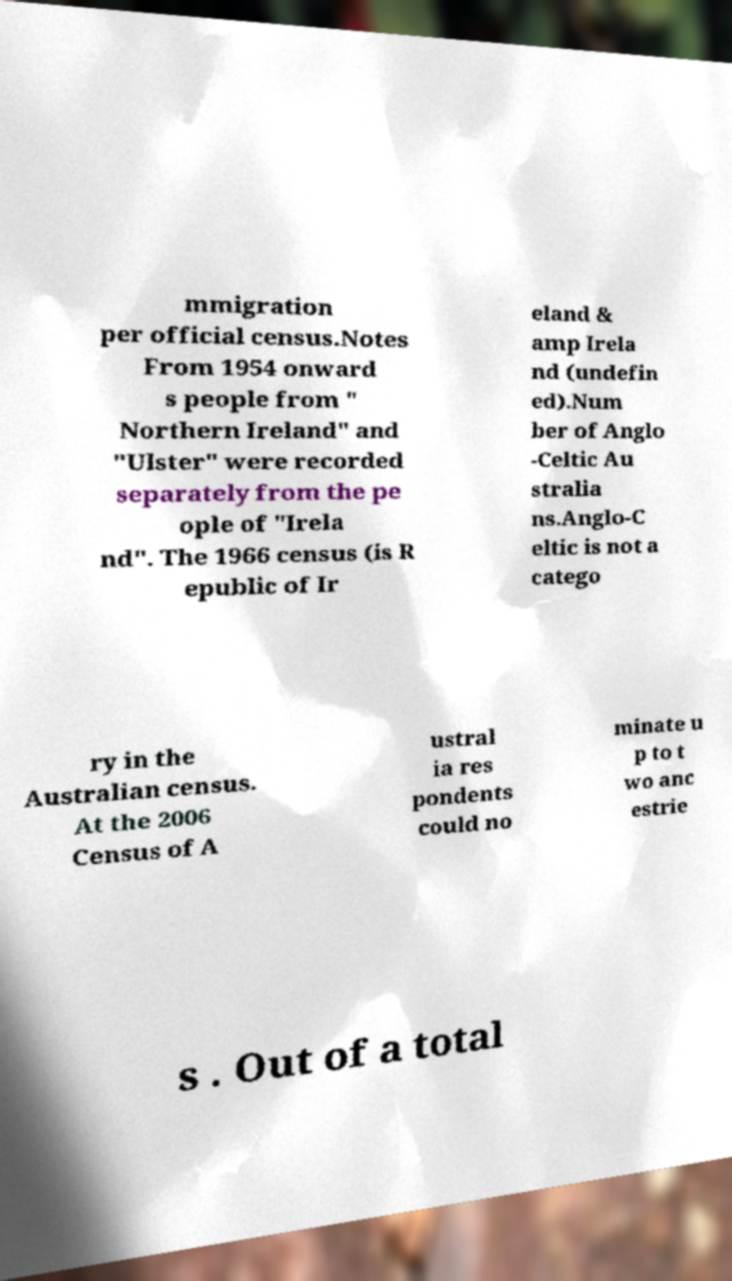Please read and relay the text visible in this image. What does it say? mmigration per official census.Notes From 1954 onward s people from " Northern Ireland" and "Ulster" were recorded separately from the pe ople of "Irela nd". The 1966 census (is R epublic of Ir eland & amp Irela nd (undefin ed).Num ber of Anglo -Celtic Au stralia ns.Anglo-C eltic is not a catego ry in the Australian census. At the 2006 Census of A ustral ia res pondents could no minate u p to t wo anc estrie s . Out of a total 